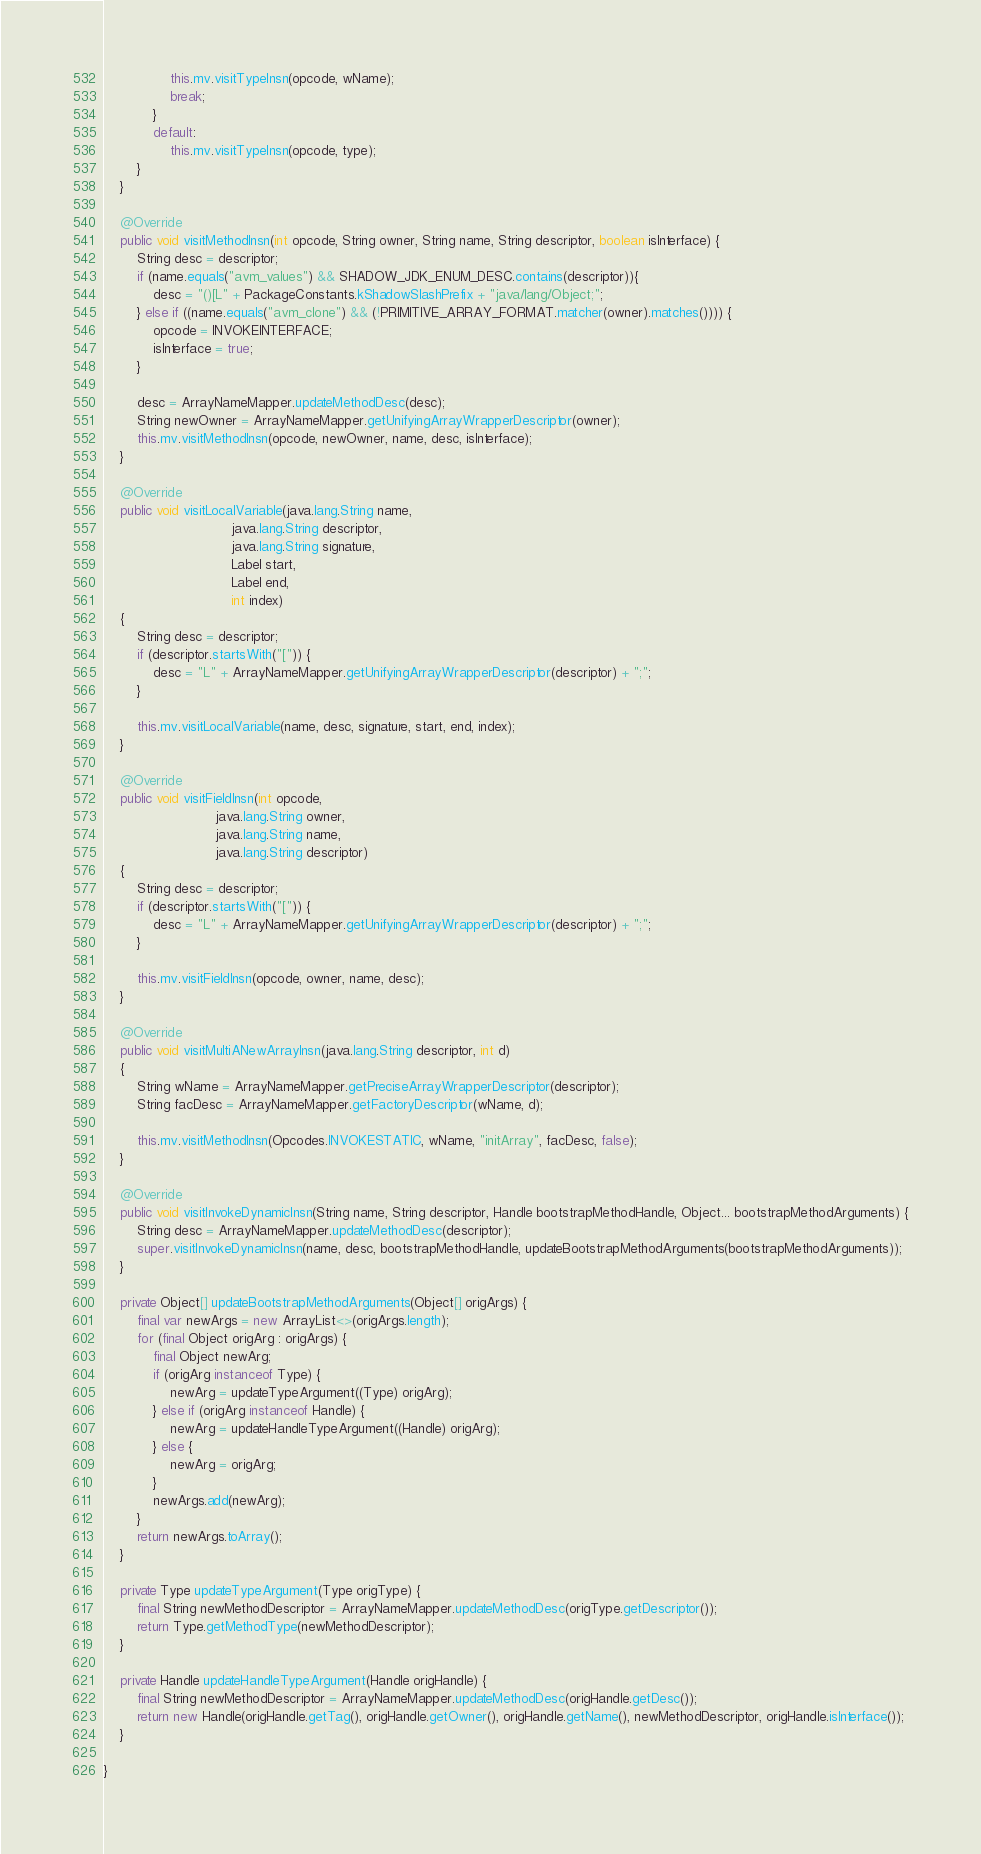Convert code to text. <code><loc_0><loc_0><loc_500><loc_500><_Java_>                this.mv.visitTypeInsn(opcode, wName);
                break;
            }
            default:
                this.mv.visitTypeInsn(opcode, type);
        }
    }

    @Override
    public void visitMethodInsn(int opcode, String owner, String name, String descriptor, boolean isInterface) {
        String desc = descriptor;
        if (name.equals("avm_values") && SHADOW_JDK_ENUM_DESC.contains(descriptor)){
            desc = "()[L" + PackageConstants.kShadowSlashPrefix + "java/lang/Object;";
        } else if ((name.equals("avm_clone") && (!PRIMITIVE_ARRAY_FORMAT.matcher(owner).matches()))) {
            opcode = INVOKEINTERFACE;
            isInterface = true;
        }

        desc = ArrayNameMapper.updateMethodDesc(desc);
        String newOwner = ArrayNameMapper.getUnifyingArrayWrapperDescriptor(owner);
        this.mv.visitMethodInsn(opcode, newOwner, name, desc, isInterface);
    }

    @Override
    public void visitLocalVariable(java.lang.String name,
                               java.lang.String descriptor,
                               java.lang.String signature,
                               Label start,
                               Label end,
                               int index)
    {
        String desc = descriptor;
        if (descriptor.startsWith("[")) {
            desc = "L" + ArrayNameMapper.getUnifyingArrayWrapperDescriptor(descriptor) + ";";
        }

        this.mv.visitLocalVariable(name, desc, signature, start, end, index);
    }

    @Override
    public void visitFieldInsn(int opcode,
                           java.lang.String owner,
                           java.lang.String name,
                           java.lang.String descriptor)
    {
        String desc = descriptor;
        if (descriptor.startsWith("[")) {
            desc = "L" + ArrayNameMapper.getUnifyingArrayWrapperDescriptor(descriptor) + ";";
        }

        this.mv.visitFieldInsn(opcode, owner, name, desc);
    }

    @Override
    public void visitMultiANewArrayInsn(java.lang.String descriptor, int d)
    {
        String wName = ArrayNameMapper.getPreciseArrayWrapperDescriptor(descriptor);
        String facDesc = ArrayNameMapper.getFactoryDescriptor(wName, d);

        this.mv.visitMethodInsn(Opcodes.INVOKESTATIC, wName, "initArray", facDesc, false);
    }

    @Override
    public void visitInvokeDynamicInsn(String name, String descriptor, Handle bootstrapMethodHandle, Object... bootstrapMethodArguments) {
        String desc = ArrayNameMapper.updateMethodDesc(descriptor);
        super.visitInvokeDynamicInsn(name, desc, bootstrapMethodHandle, updateBootstrapMethodArguments(bootstrapMethodArguments));
    }

    private Object[] updateBootstrapMethodArguments(Object[] origArgs) {
        final var newArgs = new ArrayList<>(origArgs.length);
        for (final Object origArg : origArgs) {
            final Object newArg;
            if (origArg instanceof Type) {
                newArg = updateTypeArgument((Type) origArg);
            } else if (origArg instanceof Handle) {
                newArg = updateHandleTypeArgument((Handle) origArg);
            } else {
                newArg = origArg;
            }
            newArgs.add(newArg);
        }
        return newArgs.toArray();
    }

    private Type updateTypeArgument(Type origType) {
        final String newMethodDescriptor = ArrayNameMapper.updateMethodDesc(origType.getDescriptor());
        return Type.getMethodType(newMethodDescriptor);
    }

    private Handle updateHandleTypeArgument(Handle origHandle) {
        final String newMethodDescriptor = ArrayNameMapper.updateMethodDesc(origHandle.getDesc());
        return new Handle(origHandle.getTag(), origHandle.getOwner(), origHandle.getName(), newMethodDescriptor, origHandle.isInterface());
    }

}
</code> 